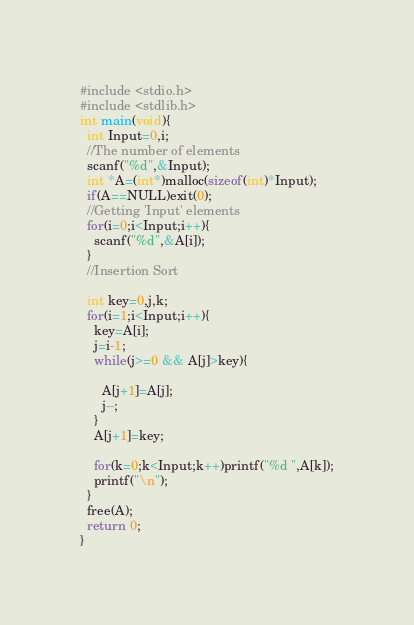Convert code to text. <code><loc_0><loc_0><loc_500><loc_500><_C_>#include <stdio.h>
#include <stdlib.h>
int main(void){
  int Input=0,i;
  //The number of elements
  scanf("%d",&Input);
  int *A=(int*)malloc(sizeof(int)*Input);
  if(A==NULL)exit(0);
  //Getting 'Input' elements
  for(i=0;i<Input;i++){
    scanf("%d",&A[i]);
  }
  //Insertion Sort

  int key=0,j,k;
  for(i=1;i<Input;i++){
    key=A[i];
    j=i-1;
    while(j>=0 && A[j]>key){

      A[j+1]=A[j];
      j--;
    }
    A[j+1]=key;

    for(k=0;k<Input;k++)printf("%d ",A[k]);
    printf("\n");
  }
  free(A);
  return 0;
}</code> 